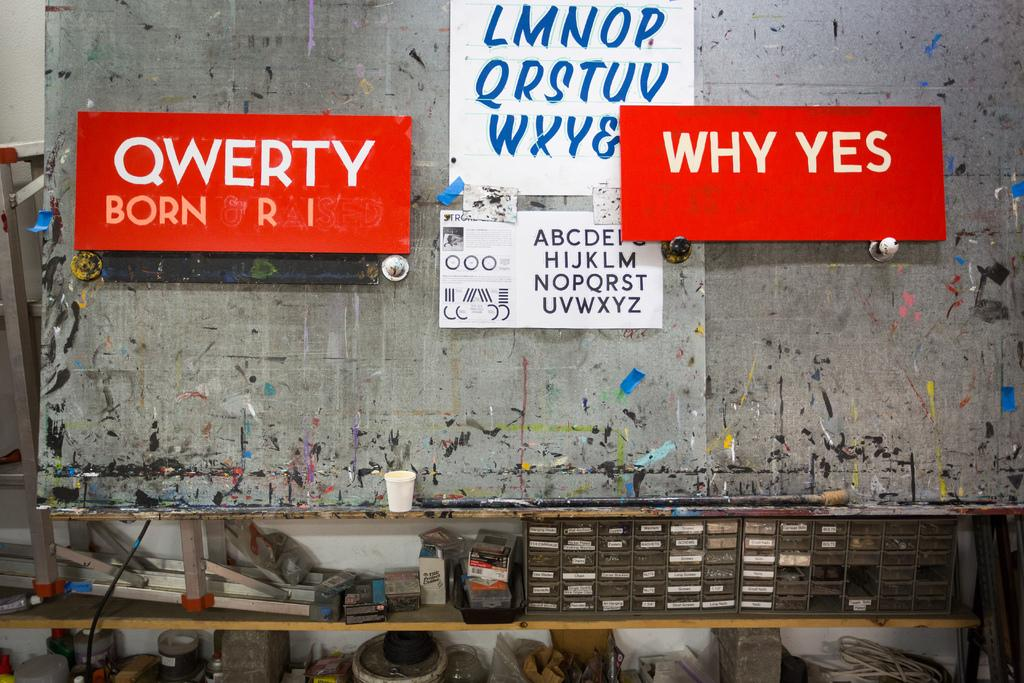<image>
Give a short and clear explanation of the subsequent image. In a workshop, a red sign displays the phrase WHY YES next to an alphabet poster and another sign with QWERTY on it. 